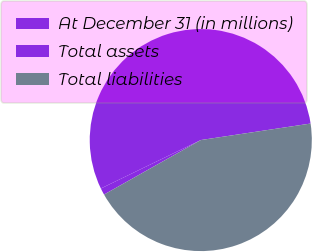<chart> <loc_0><loc_0><loc_500><loc_500><pie_chart><fcel>At December 31 (in millions)<fcel>Total assets<fcel>Total liabilities<nl><fcel>0.98%<fcel>54.81%<fcel>44.21%<nl></chart> 